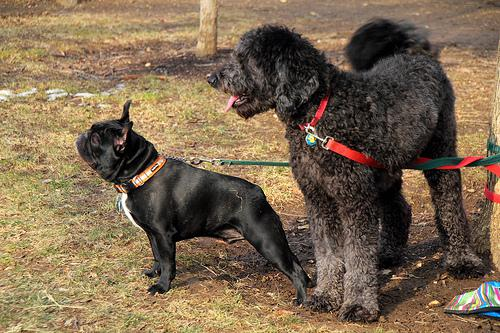Question: what color are the leashes?
Choices:
A. Pink and white.
B. Red and green.
C. Blue and yellow.
D. Orange and black.
Answer with the letter. Answer: B Question: how many dogs are there?
Choices:
A. 3.
B. 2.
C. 4.
D. 1.
Answer with the letter. Answer: B Question: who is in the picture?
Choices:
A. People.
B. Children.
C. Dogs.
D. A couple.
Answer with the letter. Answer: C 